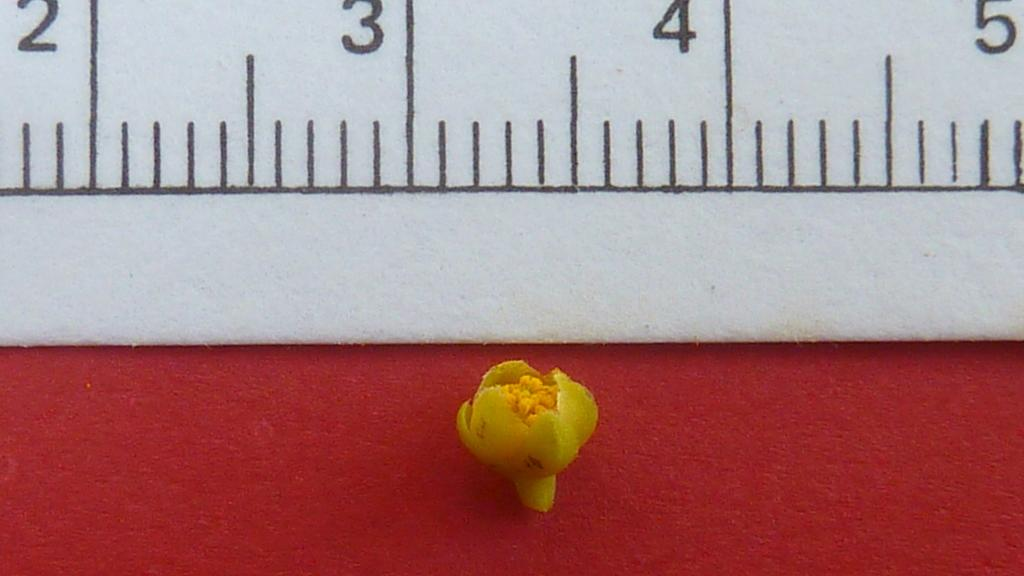Provide a one-sentence caption for the provided image. A tiny flower next to a ruler that measures it at a half inch. 